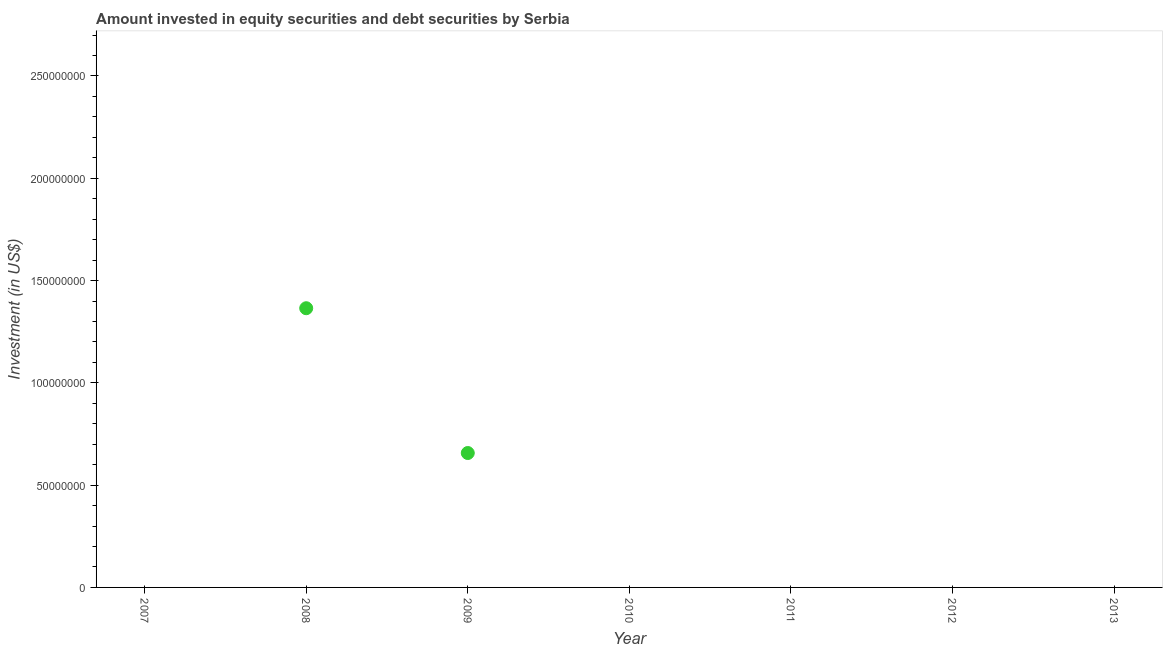What is the portfolio investment in 2013?
Offer a terse response. 0. Across all years, what is the maximum portfolio investment?
Give a very brief answer. 1.36e+08. Across all years, what is the minimum portfolio investment?
Ensure brevity in your answer.  0. In which year was the portfolio investment maximum?
Your answer should be very brief. 2008. What is the sum of the portfolio investment?
Provide a short and direct response. 2.02e+08. What is the average portfolio investment per year?
Make the answer very short. 2.89e+07. What is the median portfolio investment?
Offer a very short reply. 0. Is the difference between the portfolio investment in 2008 and 2009 greater than the difference between any two years?
Give a very brief answer. No. What is the difference between the highest and the lowest portfolio investment?
Provide a short and direct response. 1.36e+08. In how many years, is the portfolio investment greater than the average portfolio investment taken over all years?
Provide a short and direct response. 2. How many years are there in the graph?
Provide a succinct answer. 7. Are the values on the major ticks of Y-axis written in scientific E-notation?
Make the answer very short. No. What is the title of the graph?
Keep it short and to the point. Amount invested in equity securities and debt securities by Serbia. What is the label or title of the X-axis?
Offer a terse response. Year. What is the label or title of the Y-axis?
Offer a terse response. Investment (in US$). What is the Investment (in US$) in 2008?
Offer a very short reply. 1.36e+08. What is the Investment (in US$) in 2009?
Your response must be concise. 6.57e+07. What is the Investment (in US$) in 2011?
Your answer should be compact. 0. What is the Investment (in US$) in 2013?
Your answer should be compact. 0. What is the difference between the Investment (in US$) in 2008 and 2009?
Provide a short and direct response. 7.08e+07. What is the ratio of the Investment (in US$) in 2008 to that in 2009?
Offer a very short reply. 2.08. 